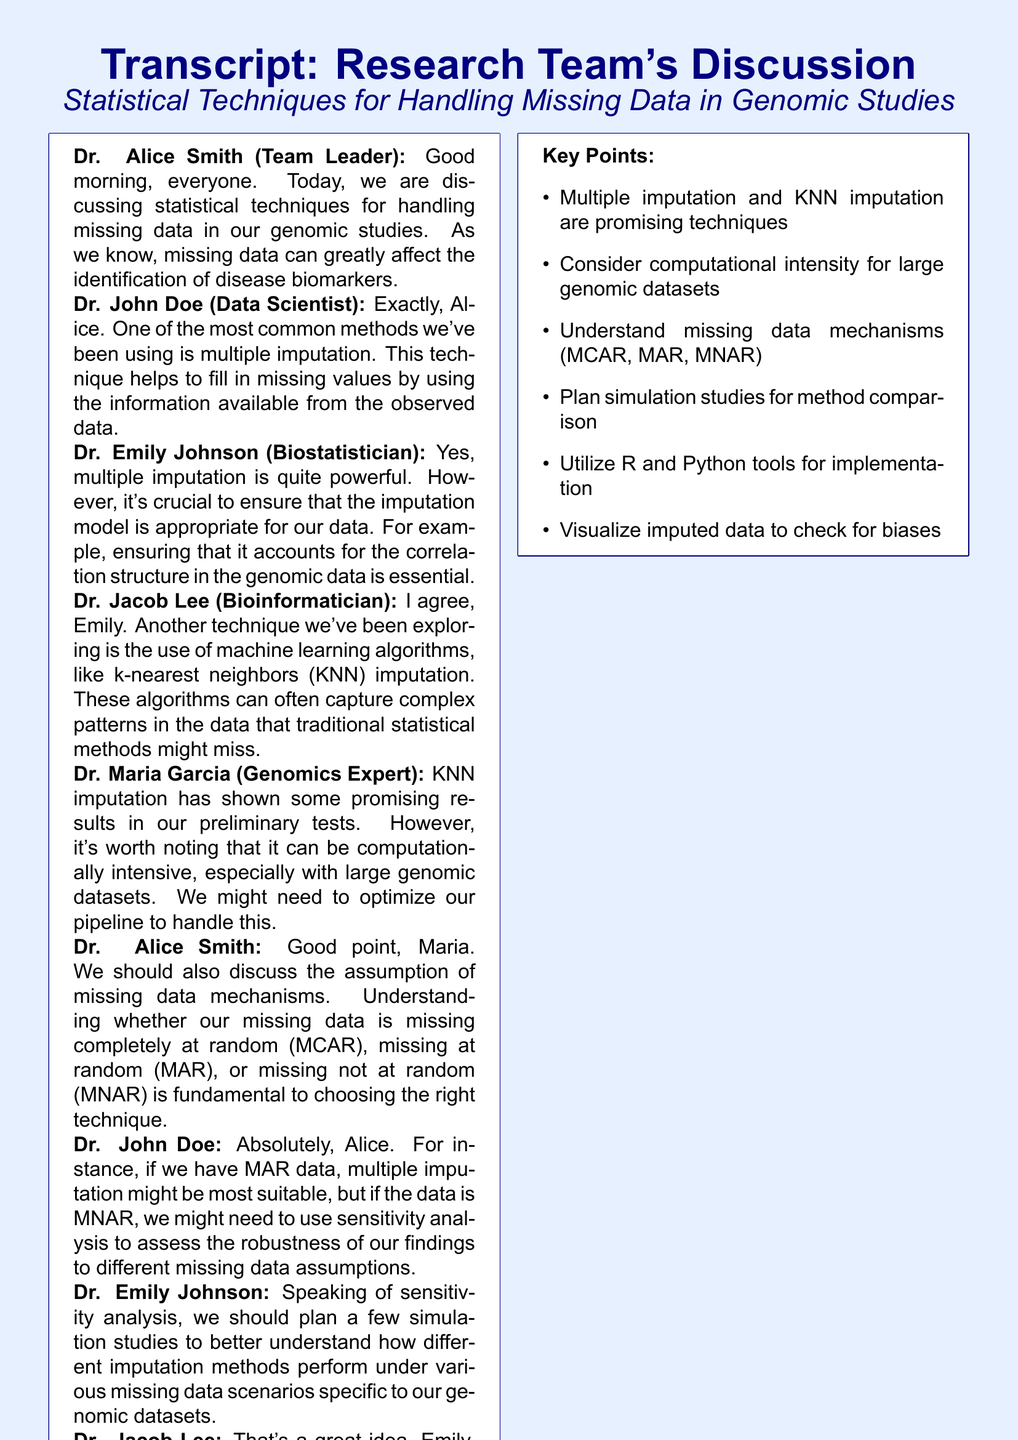What is the main topic of the discussion? The main topic of the discussion revolves around the statistical techniques for handling missing data in genomic studies.
Answer: Statistical techniques for handling missing data in genomic studies Who is the team leader? The team leader mentioned in the document is Dr. Alice Smith.
Answer: Dr. Alice Smith What imputation technique did Dr. John Doe highlight? Dr. John Doe highlighted multiple imputation as a common method used to handle missing data.
Answer: Multiple imputation Which machine learning algorithm was mentioned for imputation? The machine learning algorithm mentioned for imputation is k-nearest neighbors (KNN).
Answer: k-nearest neighbors (KNN) What assumption types are discussed regarding missing data? The discussion includes the assumptions of missing completely at random (MCAR), missing at random (MAR), and missing not at random (MNAR).
Answer: MCAR, MAR, MNAR What are two software tools suggested for simulations? The suggested software tools for simulations are R and Python.
Answer: R and Python What did Dr. Maria Garcia emphasize about data visualization? Dr. Maria Garcia emphasized the importance of visualizing the imputed data to ensure no artificial patterns or biases are introduced.
Answer: Visualizing the imputed data What is the key point regarding the computational intensity of KNN? It's noted that KNN imputation can be computationally intensive, especially with large genomic datasets.
Answer: Computationally intensive What will Dr. John Doe and Dr. Jacob Lee focus on? They will focus on refining machine learning imputation methods.
Answer: Refine machine learning imputation methods 